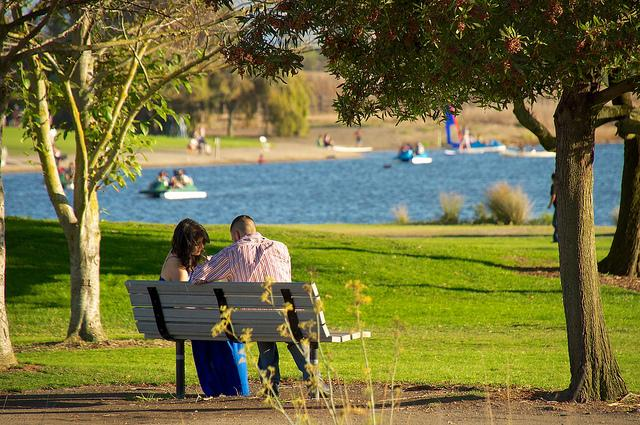What is rented for family enjoyment? boat 